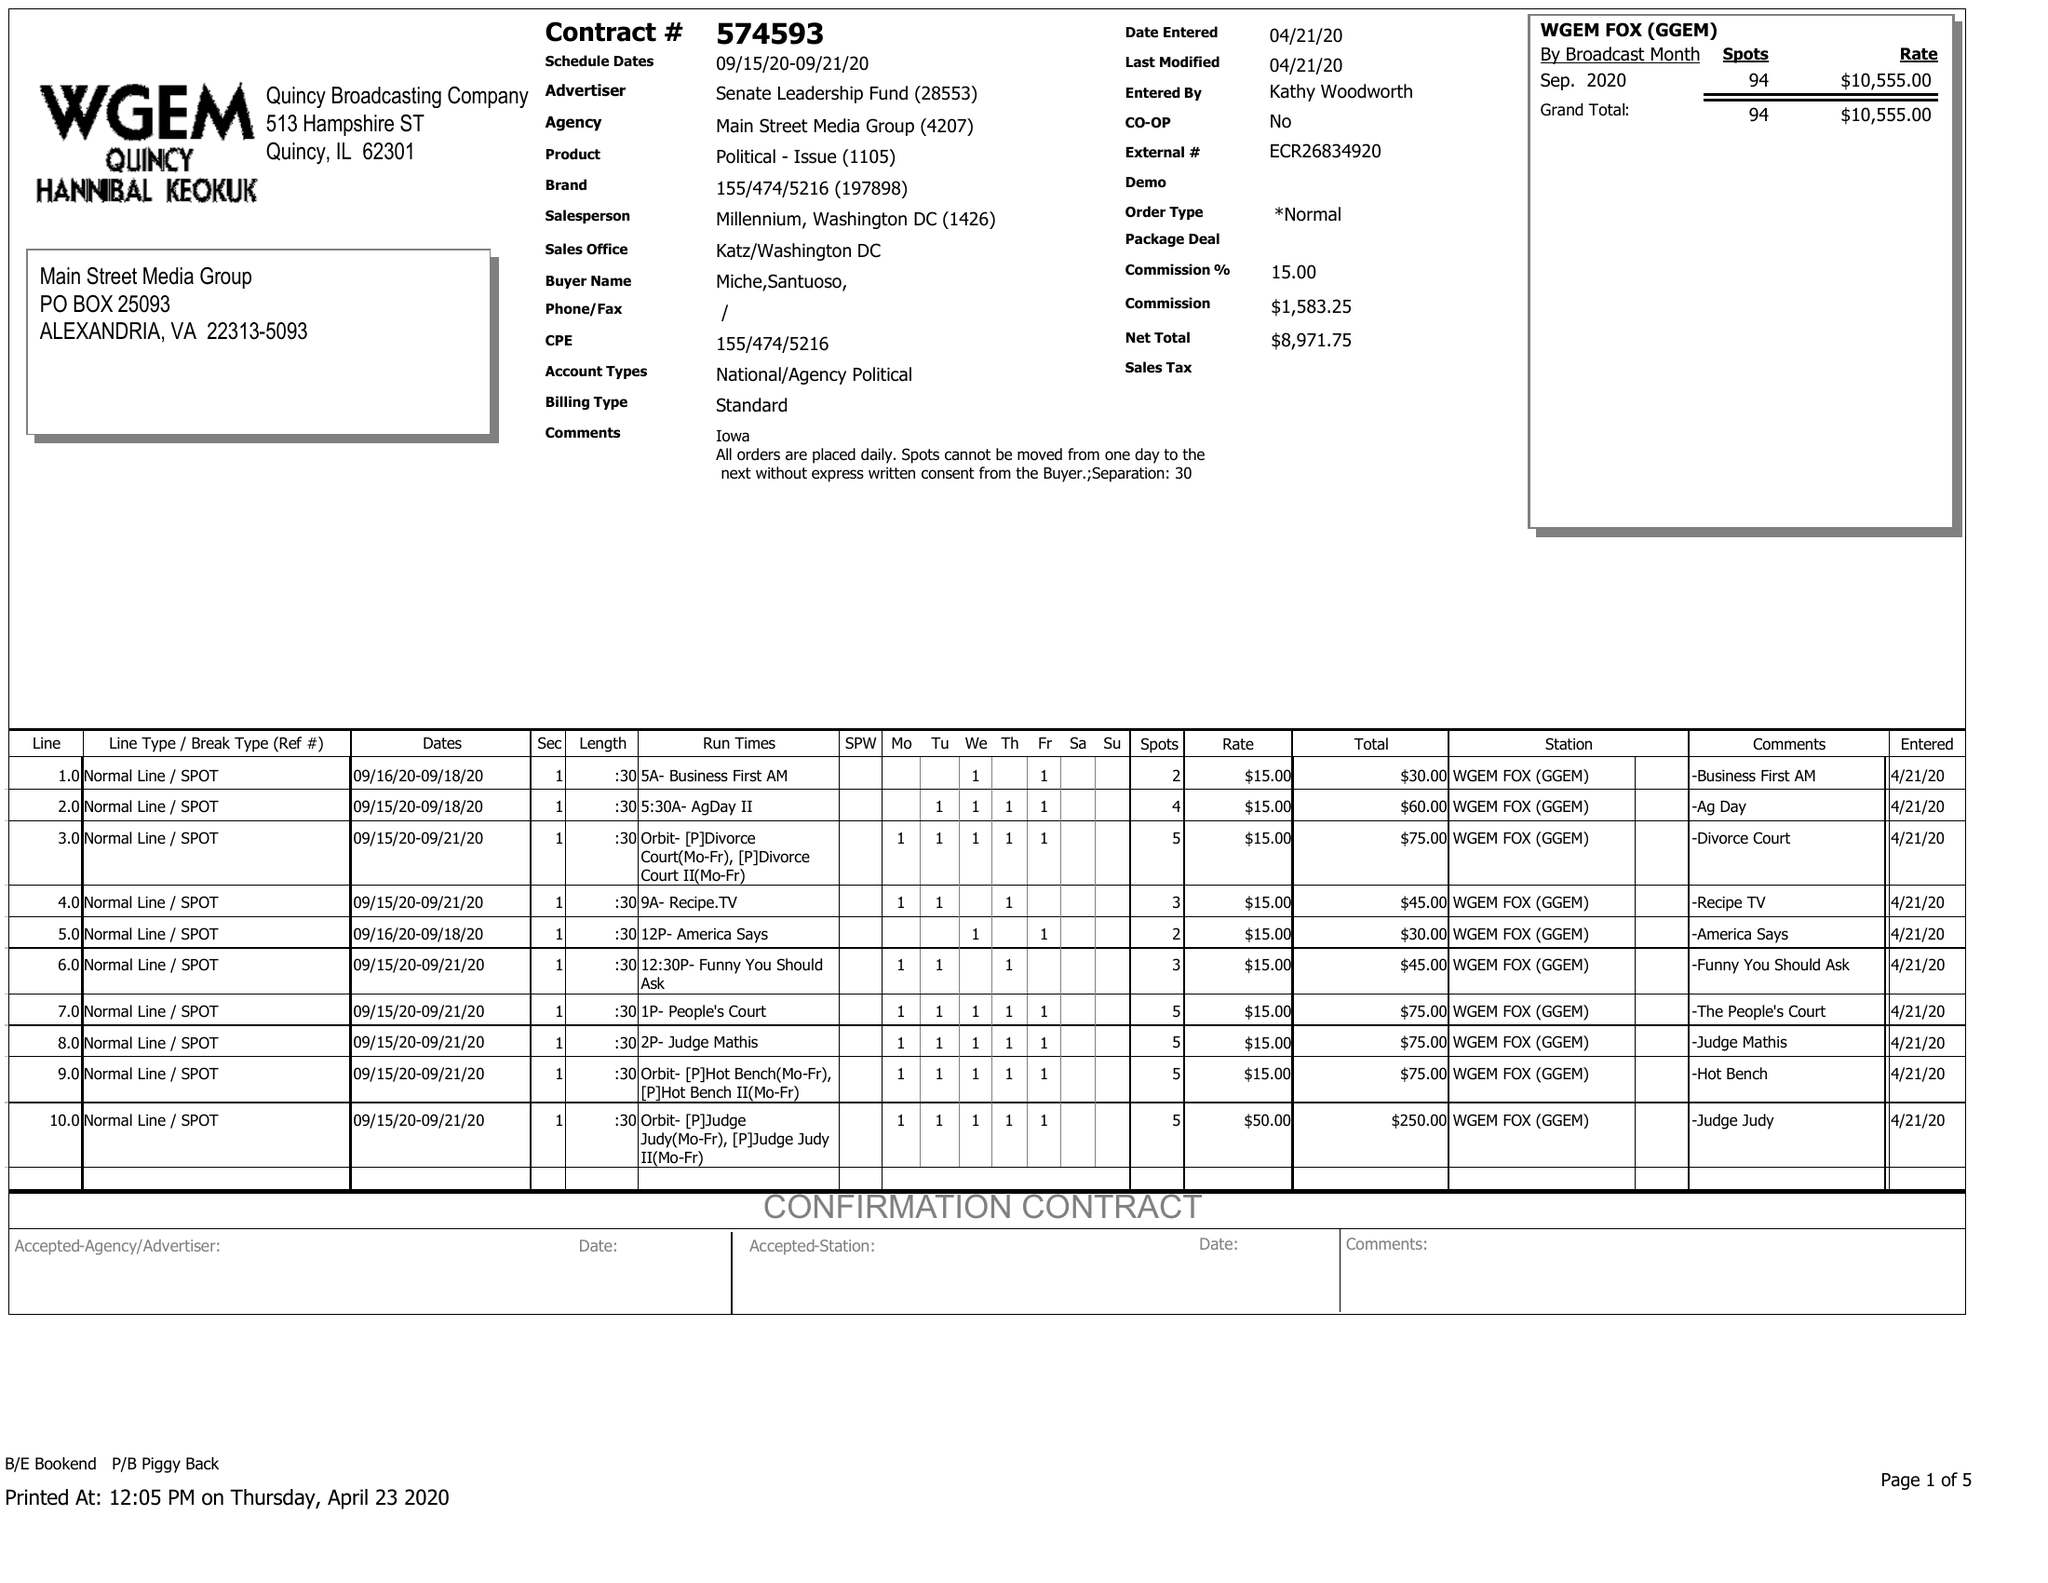What is the value for the flight_from?
Answer the question using a single word or phrase. 09/15/20 